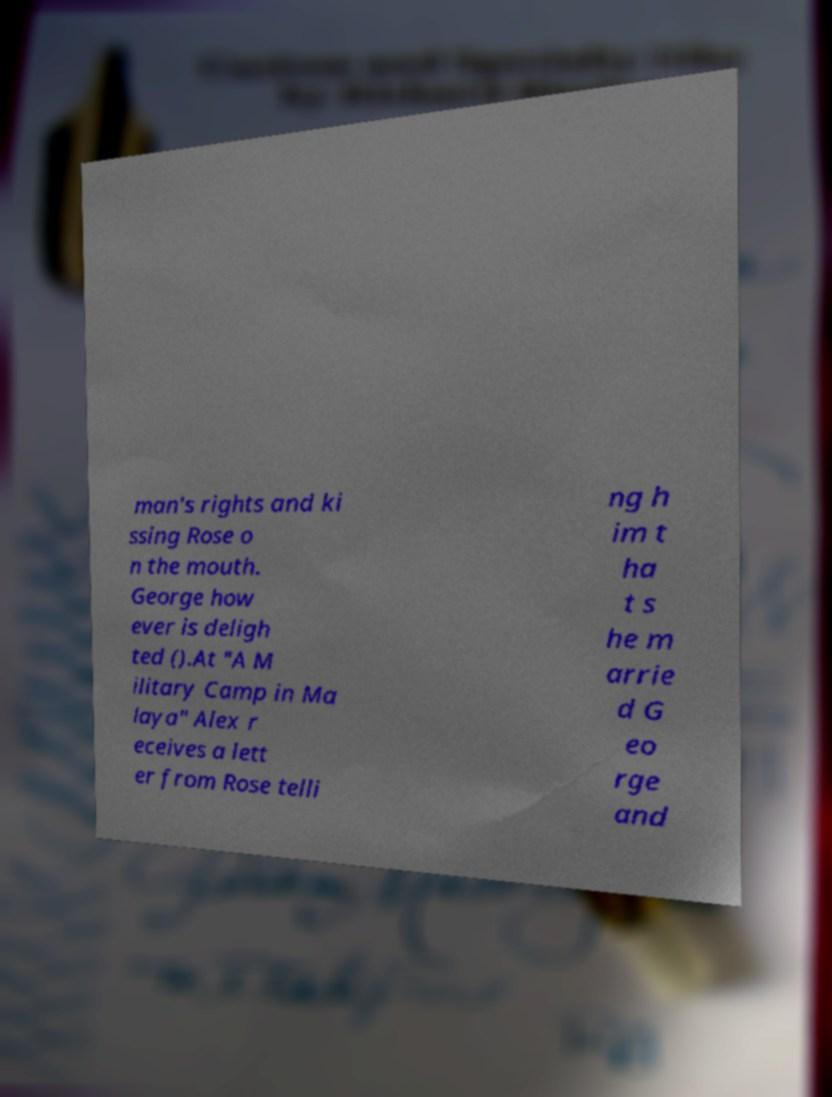Can you accurately transcribe the text from the provided image for me? man's rights and ki ssing Rose o n the mouth. George how ever is deligh ted ().At "A M ilitary Camp in Ma laya" Alex r eceives a lett er from Rose telli ng h im t ha t s he m arrie d G eo rge and 